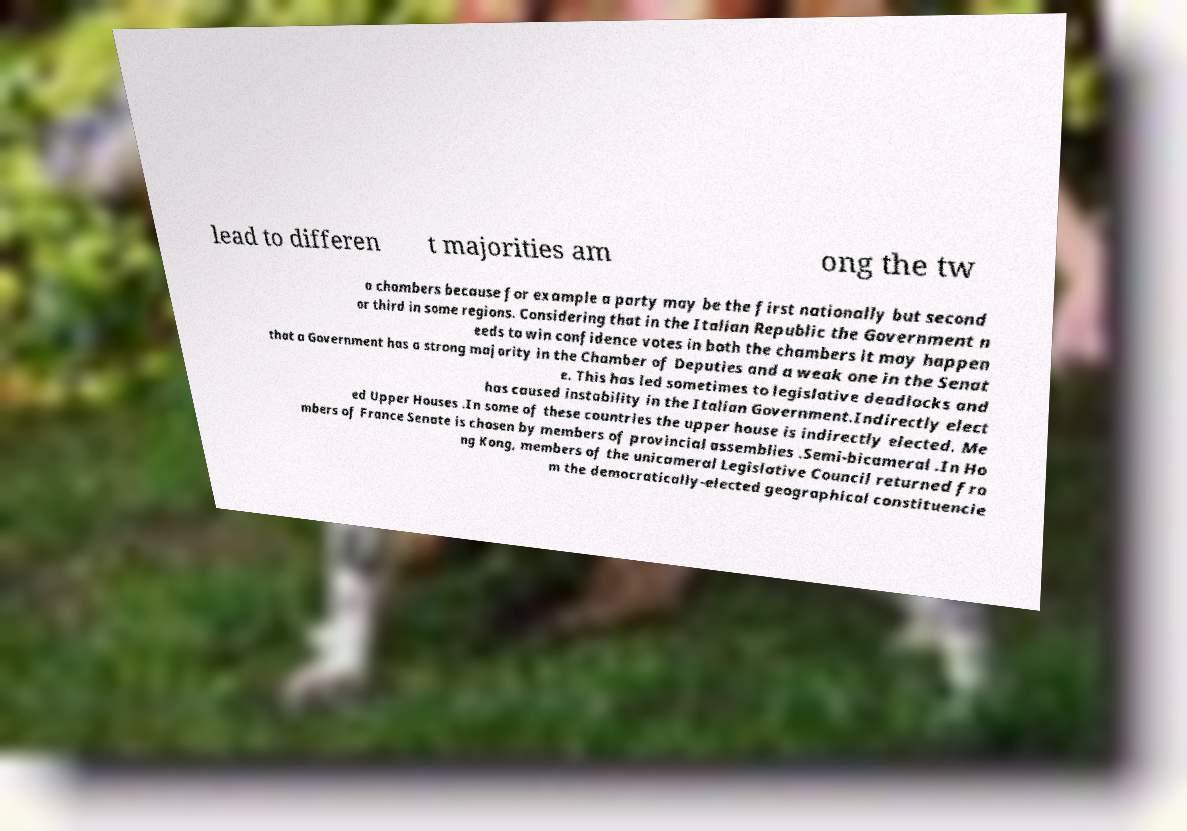Could you extract and type out the text from this image? lead to differen t majorities am ong the tw o chambers because for example a party may be the first nationally but second or third in some regions. Considering that in the Italian Republic the Government n eeds to win confidence votes in both the chambers it may happen that a Government has a strong majority in the Chamber of Deputies and a weak one in the Senat e. This has led sometimes to legislative deadlocks and has caused instability in the Italian Government.Indirectly elect ed Upper Houses .In some of these countries the upper house is indirectly elected. Me mbers of France Senate is chosen by members of provincial assemblies .Semi-bicameral .In Ho ng Kong, members of the unicameral Legislative Council returned fro m the democratically-elected geographical constituencie 